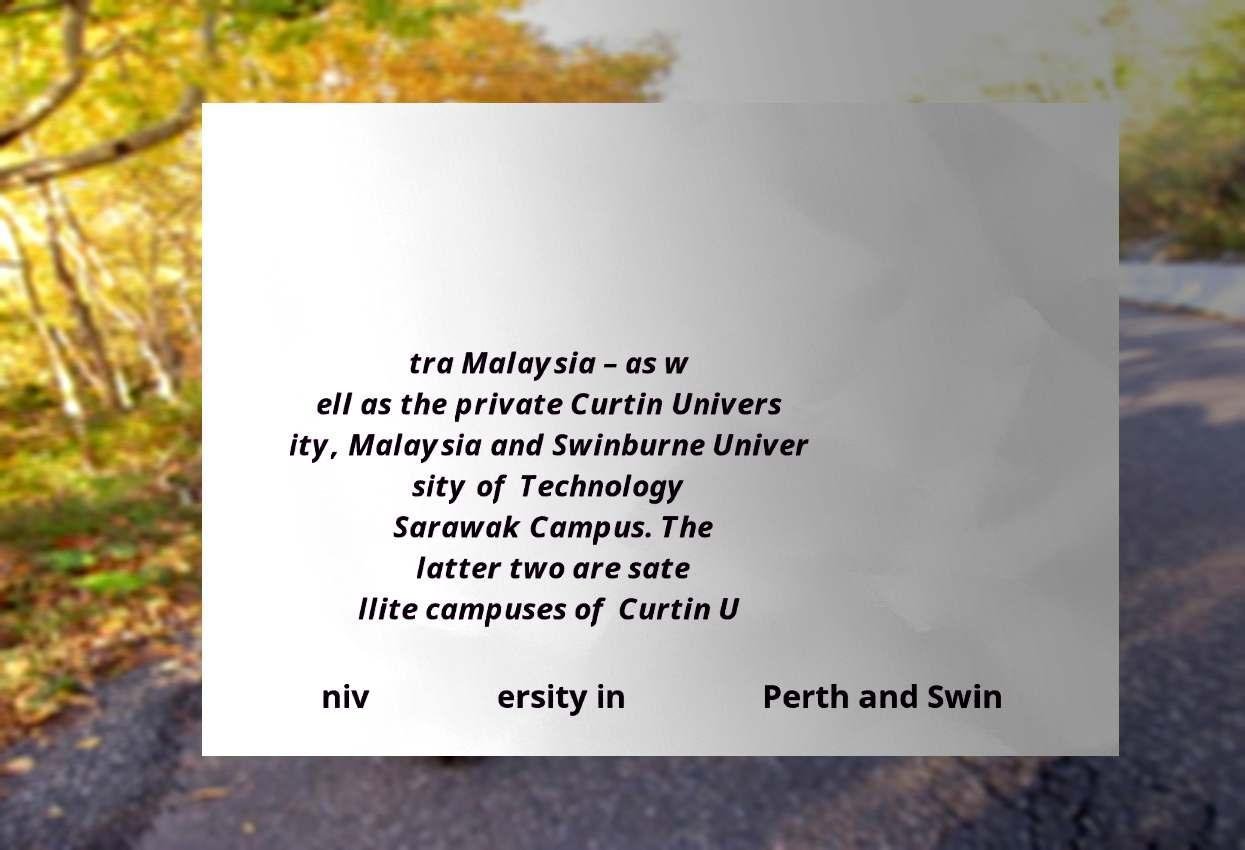Please read and relay the text visible in this image. What does it say? tra Malaysia – as w ell as the private Curtin Univers ity, Malaysia and Swinburne Univer sity of Technology Sarawak Campus. The latter two are sate llite campuses of Curtin U niv ersity in Perth and Swin 